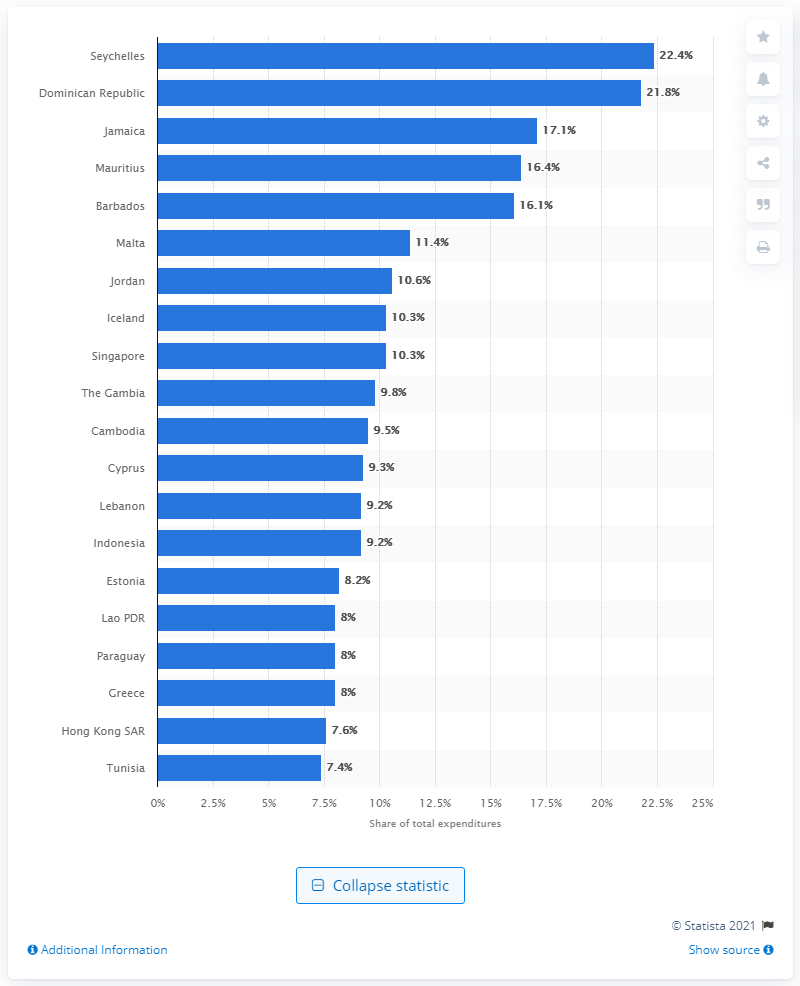Indicate a few pertinent items in this graphic. According to the data, Jamaica allocated 17.1% of their budget towards travel and tourism in 2020. 